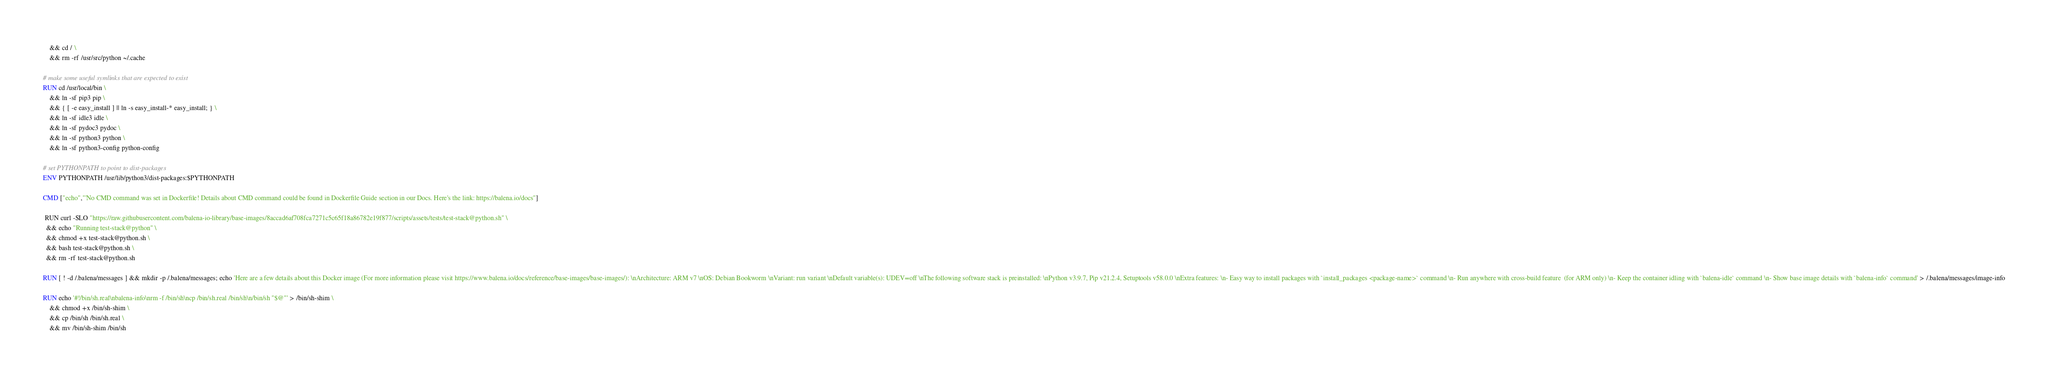<code> <loc_0><loc_0><loc_500><loc_500><_Dockerfile_>	&& cd / \
	&& rm -rf /usr/src/python ~/.cache

# make some useful symlinks that are expected to exist
RUN cd /usr/local/bin \
	&& ln -sf pip3 pip \
	&& { [ -e easy_install ] || ln -s easy_install-* easy_install; } \
	&& ln -sf idle3 idle \
	&& ln -sf pydoc3 pydoc \
	&& ln -sf python3 python \
	&& ln -sf python3-config python-config

# set PYTHONPATH to point to dist-packages
ENV PYTHONPATH /usr/lib/python3/dist-packages:$PYTHONPATH

CMD ["echo","'No CMD command was set in Dockerfile! Details about CMD command could be found in Dockerfile Guide section in our Docs. Here's the link: https://balena.io/docs"]

 RUN curl -SLO "https://raw.githubusercontent.com/balena-io-library/base-images/8accad6af708fca7271c5c65f18a86782e19f877/scripts/assets/tests/test-stack@python.sh" \
  && echo "Running test-stack@python" \
  && chmod +x test-stack@python.sh \
  && bash test-stack@python.sh \
  && rm -rf test-stack@python.sh 

RUN [ ! -d /.balena/messages ] && mkdir -p /.balena/messages; echo 'Here are a few details about this Docker image (For more information please visit https://www.balena.io/docs/reference/base-images/base-images/): \nArchitecture: ARM v7 \nOS: Debian Bookworm \nVariant: run variant \nDefault variable(s): UDEV=off \nThe following software stack is preinstalled: \nPython v3.9.7, Pip v21.2.4, Setuptools v58.0.0 \nExtra features: \n- Easy way to install packages with `install_packages <package-name>` command \n- Run anywhere with cross-build feature  (for ARM only) \n- Keep the container idling with `balena-idle` command \n- Show base image details with `balena-info` command' > /.balena/messages/image-info

RUN echo '#!/bin/sh.real\nbalena-info\nrm -f /bin/sh\ncp /bin/sh.real /bin/sh\n/bin/sh "$@"' > /bin/sh-shim \
	&& chmod +x /bin/sh-shim \
	&& cp /bin/sh /bin/sh.real \
	&& mv /bin/sh-shim /bin/sh</code> 